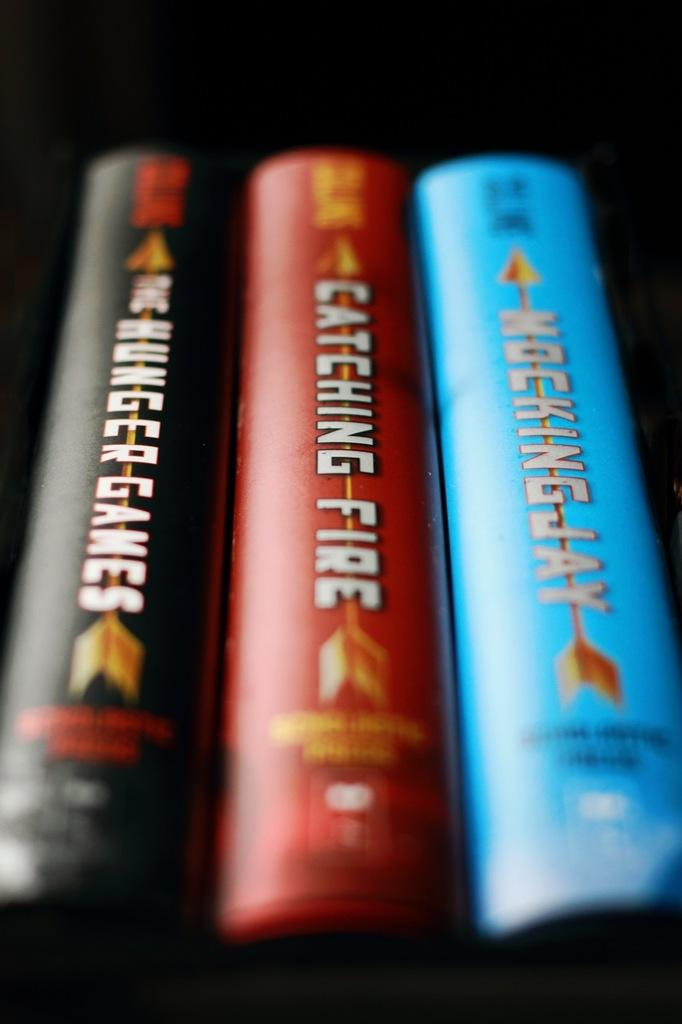<image>
Write a terse but informative summary of the picture. Three books in a row with Catching Fire in the middle. 